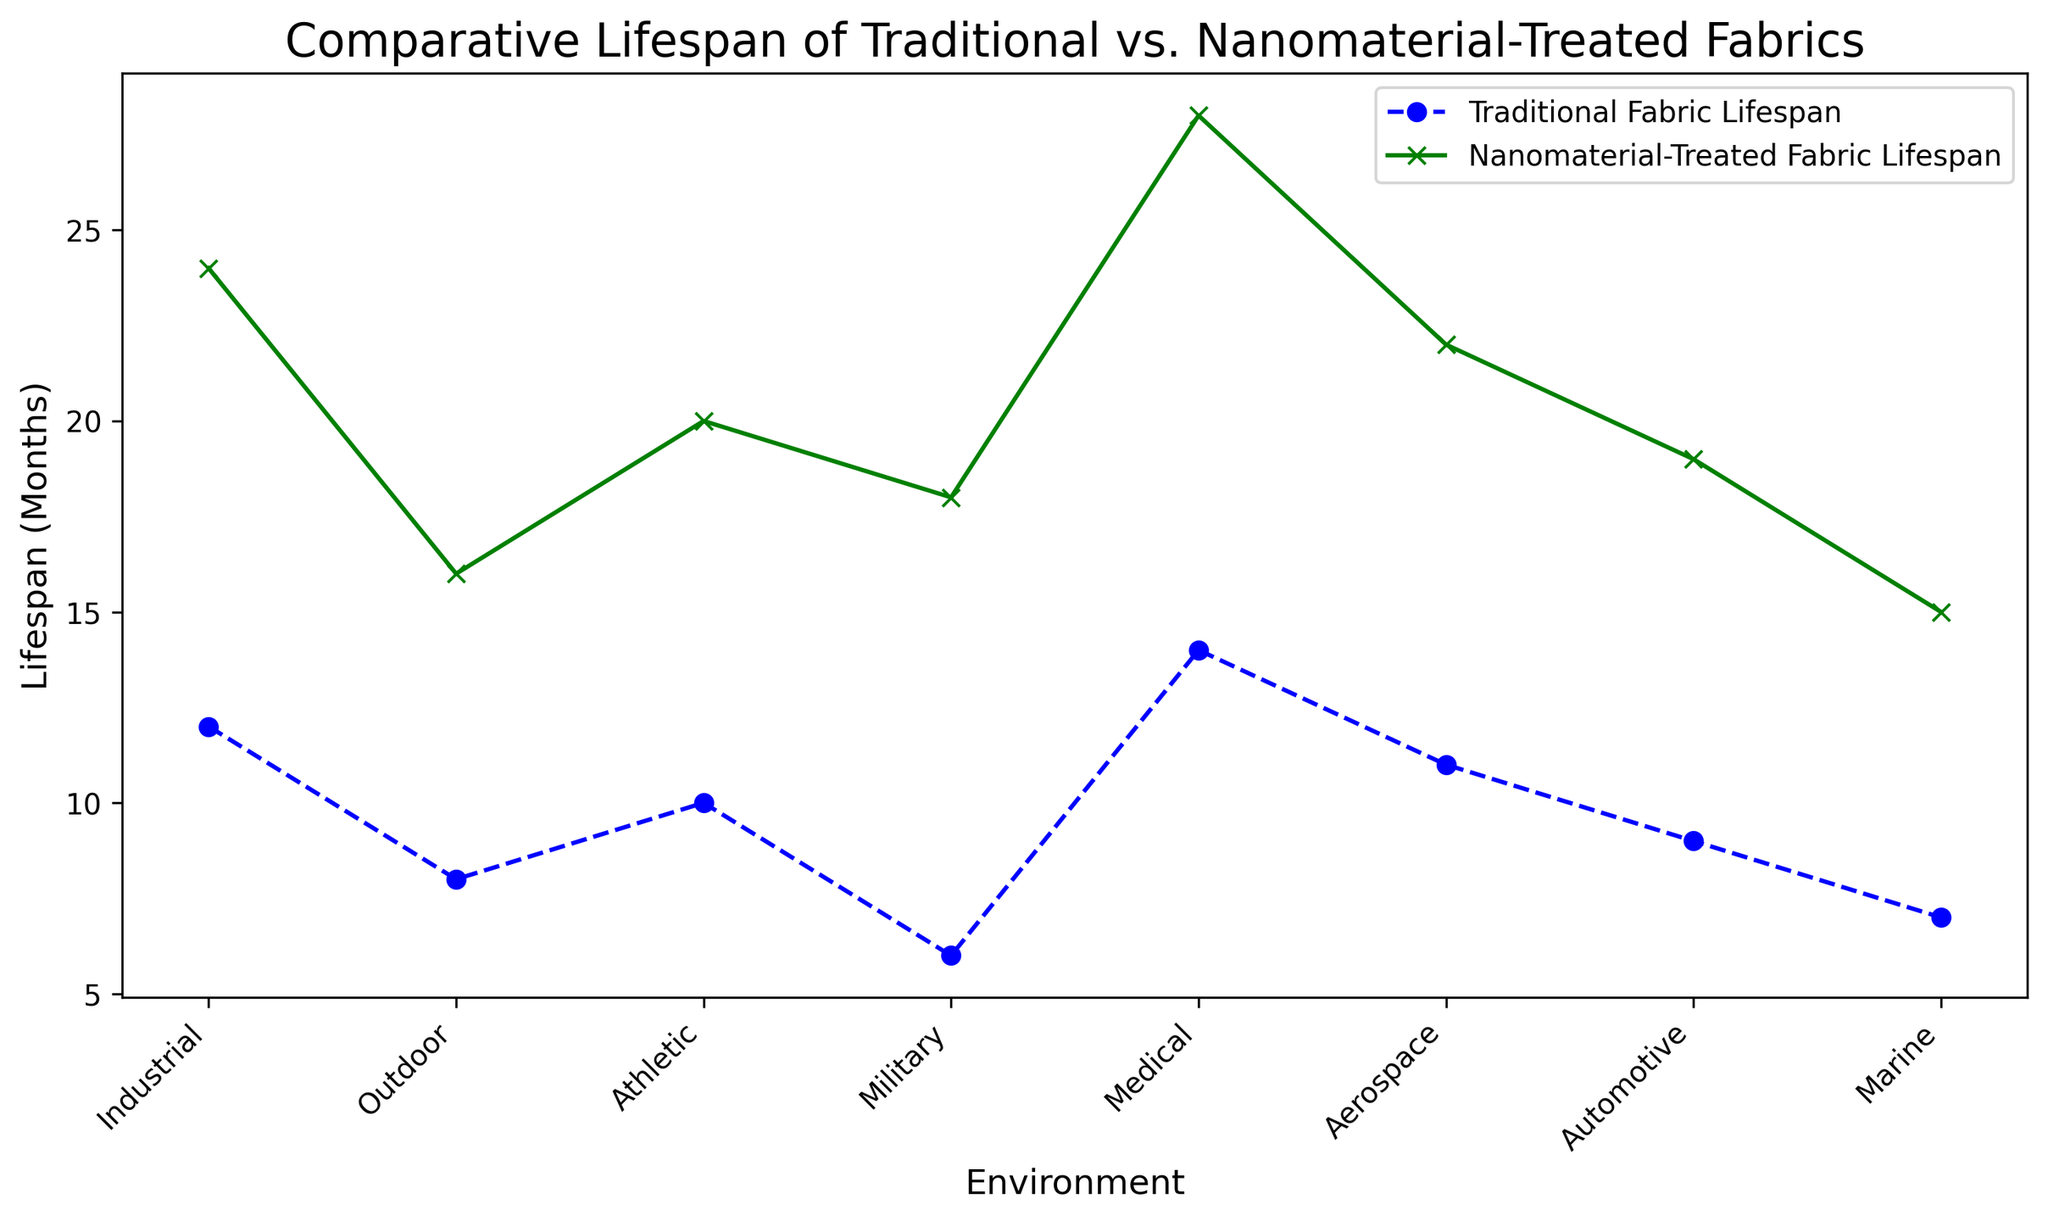Which environment shows the greatest difference in lifespan between traditional and nanomaterial-treated fabrics? To find the greatest difference, subtract the lifespan of traditional fabric from the nanomaterial-treated fabric for each environment. The differences are: Industrial (12), Outdoor (8), Athletic (10), Military (12), Medical (14), Aerospace (11), Automotive (10), Marine (8). The greatest difference is 14 months in the Medical environment.
Answer: Medical What is the average lifespan of nanomaterial-treated fabrics across all environments? Add the lifespan of nanomaterial-treated fabrics in all environments and divide by the number of environments: (24 + 16 + 20 + 18 + 28 + 22 + 19 + 15) / 8 = 162 / 8 = 20.25 months.
Answer: 20.25 months Which environment has the smallest lifespan for traditional fabrics? Look at all the data points for traditional fabric lifespan and identify the smallest value. The smallest value is 6 months in the Military environment.
Answer: Military By how many months is the nanomaterial-treated fabric's lifespan greater than the traditional fabric's lifespan on average? Calculate the difference for each environment and then take the average of those differences: (12 + 8 + 10 + 12 + 14 + 11 + 10 + 8) / 8 = 85 / 8 = 10.625 months.
Answer: 10.625 months Do traditional fabrics or nanomaterial-treated fabrics show more variability in lifespan across different environments? To find variability, look at the range (max - min) of lifespans. For traditional fabrics, the range is 14 (14 - 6 = 8). For nanomaterial-treated fabrics, the range is 13 (28 - 15 = 13). Nanomaterial-treated fabrics show more variability.
Answer: Nanomaterial-treated fabrics In which environments do nanomaterial-treated fabrics last at least double the lifespan of traditional fabrics? Verify if the lifespan of nanomaterial-treated fabrics is at least twice that of traditional fabrics: 
- Industrial: 24 / 12 = 2 (yes)
- Outdoor: 16 / 8 = 2 (yes)
- Athletic: 20 / 10 = 2 (yes)
- Military: 18 / 6 = 3 (yes)
- Medical: 28 / 14 = 2 (yes)
- Aerospace: 22 / 11 = 2 (yes)
- Automotive: 19 / 9 = 2.11 (yes)
- Marine: 15 / 7 = 2.14 (yes)
So, in all environments, nanomaterial-treated fabrics last at least double.
Answer: All environments Compare the lifespan of traditional fabrics in the 'Outdoor' environment to nanomaterial-treated fabrics in the 'Automotive' environment. Which one lasts longer? Check the lifespans in the respective environments: Outdoor traditional (8 months) vs. Automotive nanomaterial-treated (19 months). 19 months is greater than 8 months, so nanomaterial-treated fabric in Automotive lasts longer.
Answer: Nanomaterial-treated fabric in Automotive What is the ratio of the lifespan of nanomaterial-treated fabrics to traditional fabrics in the Aerospace environment? Divide the lifespan of nanomaterial-treated fabric by traditional fabric in the Aerospace environment: 22 / 11 = 2.
Answer: 2 On which environment do both fabric types have the closest lifespan difference? Calculate the difference for each environment: Industrial (12), Outdoor (8), Athletic (10), Military (12), Medical (14), Aerospace (11), Automotive (10), Marine (8). The closest differences are in Outdoor and Marine environments, both having a difference of 8 months.
Answer: Outdoor and Marine If you sum the lifespan of traditional fabrics in Medical and Military environments, what do you get? Add the lifespans: Medical (14) + Military (6) = 14 + 6 = 20 months.
Answer: 20 months 